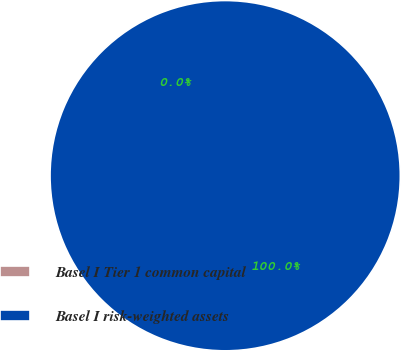Convert chart to OTSL. <chart><loc_0><loc_0><loc_500><loc_500><pie_chart><fcel>Basel I Tier 1 common capital<fcel>Basel I risk-weighted assets<nl><fcel>0.0%<fcel>100.0%<nl></chart> 